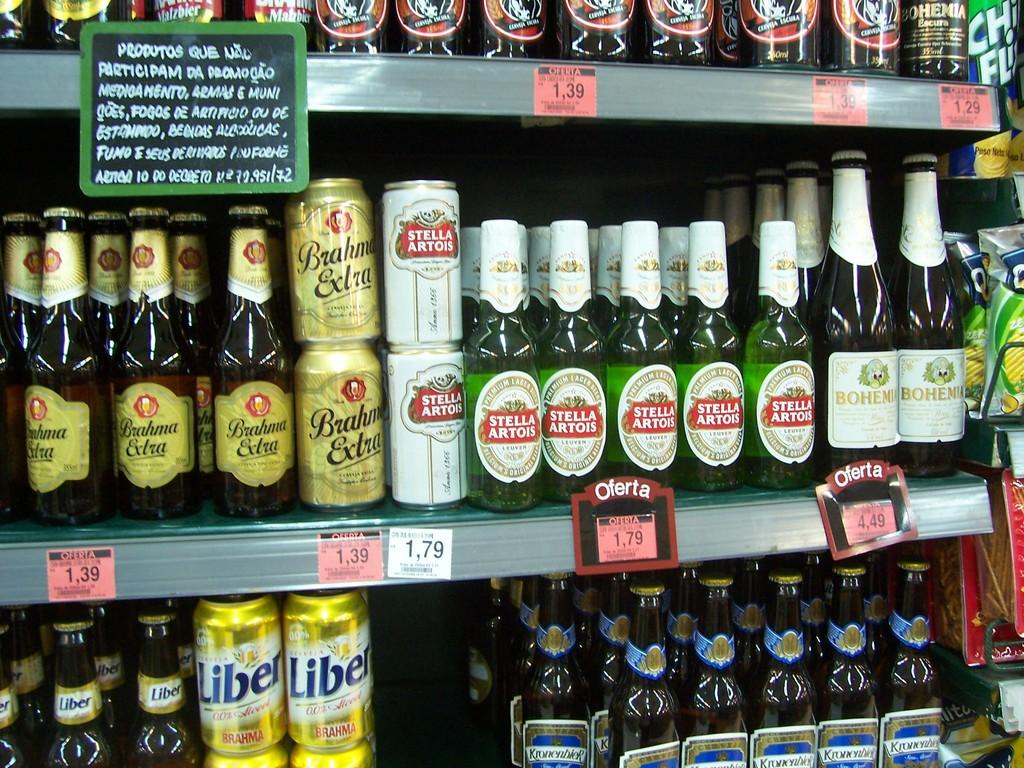What types of items are stored in the racks in the image? There are wine bottles in three racks and chips packets in three racks on the right. How many racks are there in total? There are six racks in total, with three for wine bottles and three for chips packets. Are the wine bottles and chips packets stored separately or together? The wine bottles and chips packets are stored separately, with the wine bottles on the left and the chips packets on the right. What type of pancake is being prepared for the trip in the image? There is no trip or pancake present in the image; it only features wine bottles and chips packets stored in racks. 